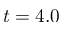Convert formula to latex. <formula><loc_0><loc_0><loc_500><loc_500>t = 4 . 0</formula> 